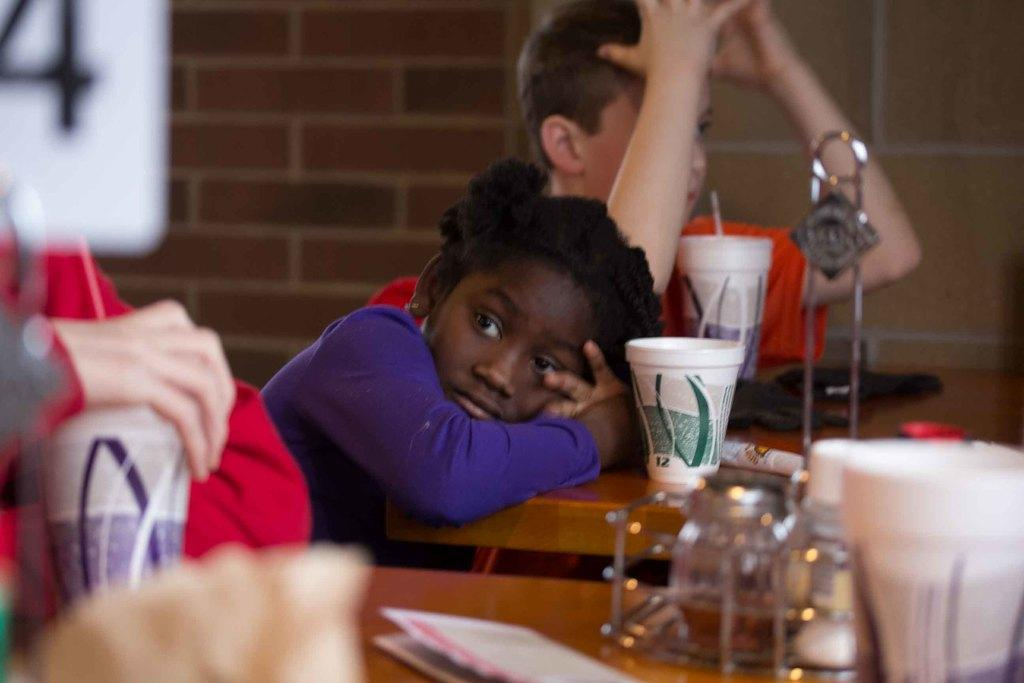Who are the people in the image? There is a boy and a girl in the image. What are the boy and girl doing in the image? Both the boy and girl are seated on chairs. What can be seen on the table in the image? There are cups on the table. What is the man in the image doing? A man is holding a cup in his hand. What type of loaf is the boy holding in the image? There is no loaf present in the image; the boy is seated on a chair and not holding anything. 